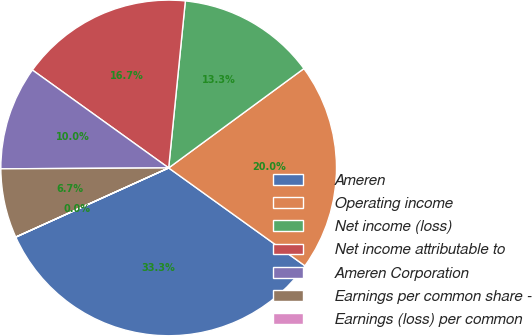Convert chart. <chart><loc_0><loc_0><loc_500><loc_500><pie_chart><fcel>Ameren<fcel>Operating income<fcel>Net income (loss)<fcel>Net income attributable to<fcel>Ameren Corporation<fcel>Earnings per common share -<fcel>Earnings (loss) per common<nl><fcel>33.32%<fcel>20.0%<fcel>13.33%<fcel>16.67%<fcel>10.0%<fcel>6.67%<fcel>0.01%<nl></chart> 